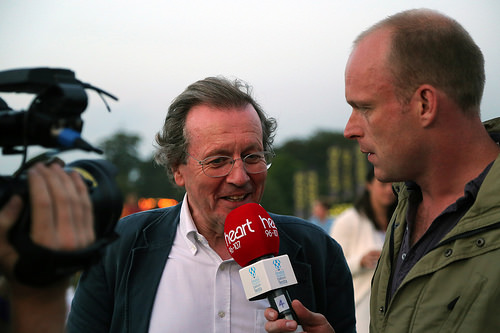<image>
Is there a man behind the mic? Yes. From this viewpoint, the man is positioned behind the mic, with the mic partially or fully occluding the man. 